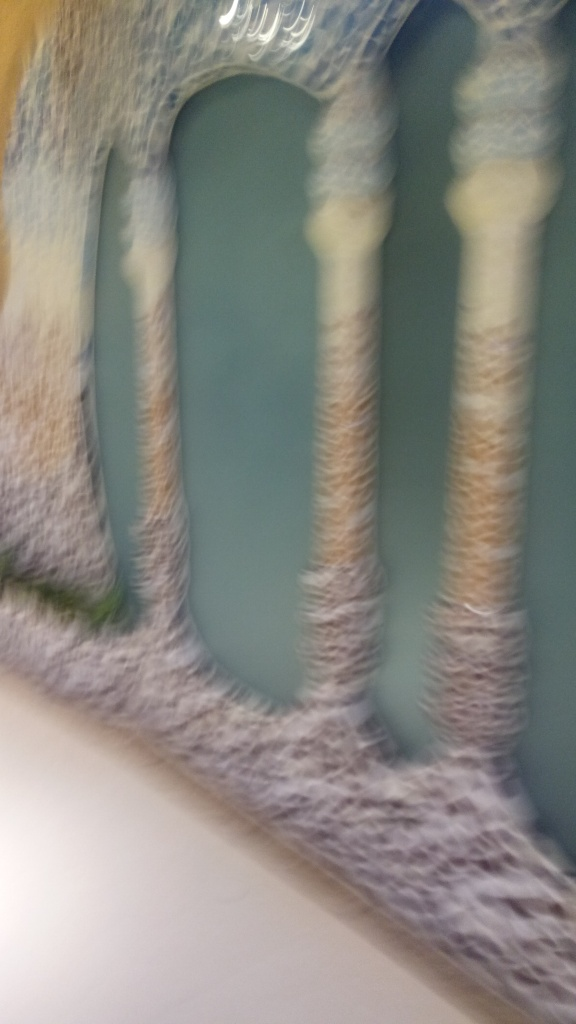How might the photographer improve the quality of an image like this in the future? To improve the quality, using a faster shutter speed or a tripod to reduce camera shake would be beneficial. Additionally, ensuring the camera is properly focused on the subject, utilizing optimal lighting conditions, or a higher resolution setting can all contribute to a sharper, higher quality image. 